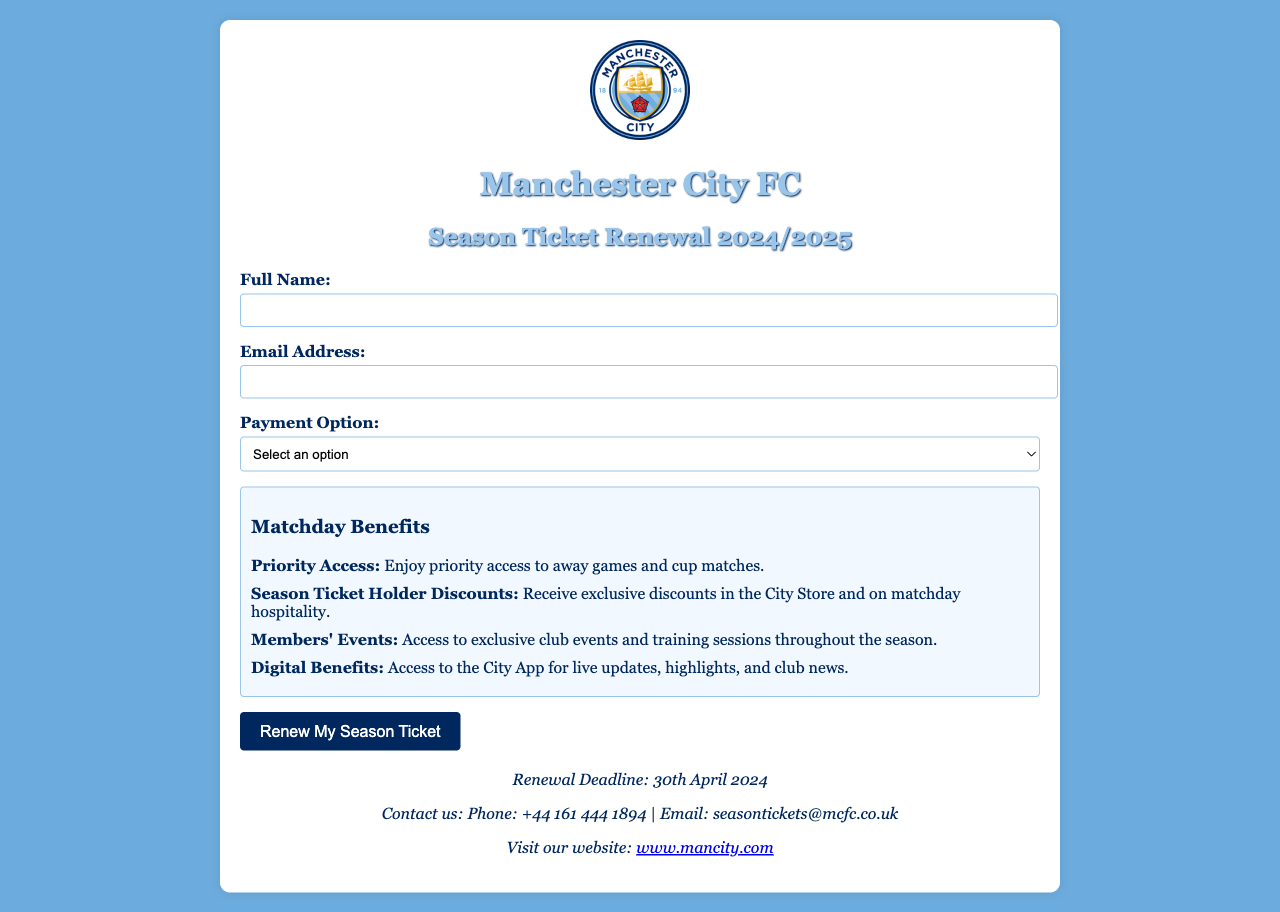what is the season for renewal? The form indicates the specific season for renewal as 2024/2025.
Answer: 2024/2025 what is the deadline for season ticket renewal? The document states that the renewal deadline is 30th April 2024.
Answer: 30th April 2024 how many payment options are available? The document lists three payment options: Full Payment, Installments, and Direct Debit.
Answer: Three what is one of the matchday benefits? The document mentions multiple matchday benefits, including Priority Access to away games and cup matches.
Answer: Priority Access what is the contact email for season ticket inquiries? The form provides a specific contact email for any inquiries regarding season tickets, which is seasontickets@mcfc.co.uk.
Answer: seasontickets@mcfc.co.uk which club is this form for? The form prominently features the Manchester City FC logo and title, indicating its affiliation.
Answer: Manchester City FC what should you do to renew your season ticket? To renew your season ticket, you need to fill out the form and click the "Renew My Season Ticket" button.
Answer: Fill out the form what is the colour of the background in the document? The background of the document is a specific shade of blue, which is #6CABDD.
Answer: Blue 